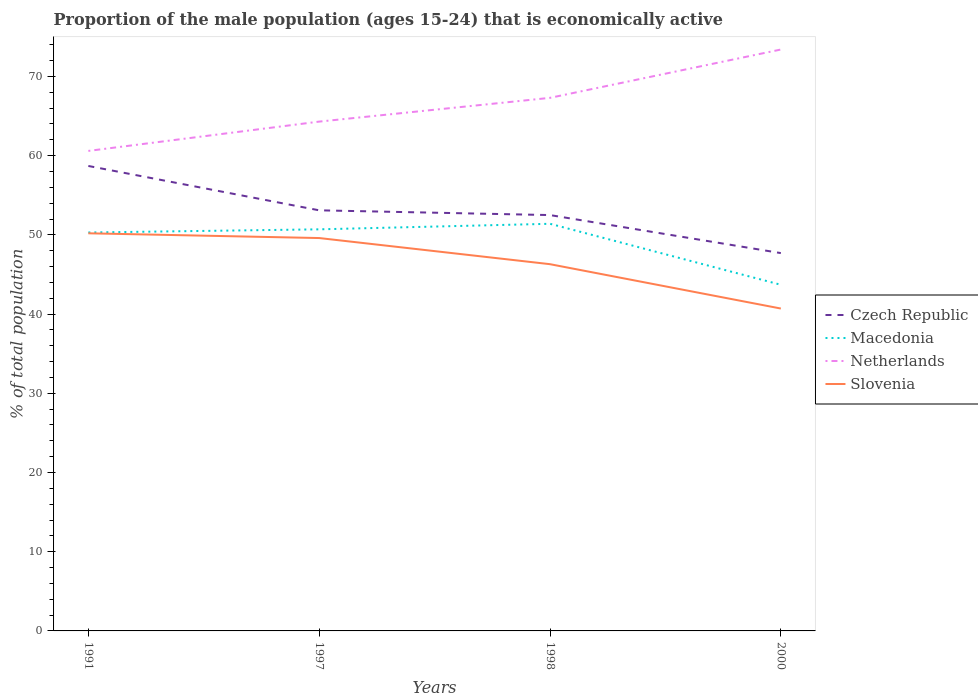How many different coloured lines are there?
Your answer should be very brief. 4. Does the line corresponding to Slovenia intersect with the line corresponding to Czech Republic?
Offer a very short reply. No. Is the number of lines equal to the number of legend labels?
Provide a succinct answer. Yes. Across all years, what is the maximum proportion of the male population that is economically active in Czech Republic?
Provide a succinct answer. 47.7. In which year was the proportion of the male population that is economically active in Macedonia maximum?
Your answer should be very brief. 2000. What is the total proportion of the male population that is economically active in Macedonia in the graph?
Keep it short and to the point. -0.7. Is the proportion of the male population that is economically active in Netherlands strictly greater than the proportion of the male population that is economically active in Macedonia over the years?
Your answer should be very brief. No. How many years are there in the graph?
Provide a succinct answer. 4. What is the difference between two consecutive major ticks on the Y-axis?
Offer a very short reply. 10. Does the graph contain grids?
Your answer should be very brief. No. Where does the legend appear in the graph?
Give a very brief answer. Center right. What is the title of the graph?
Offer a very short reply. Proportion of the male population (ages 15-24) that is economically active. Does "Togo" appear as one of the legend labels in the graph?
Offer a terse response. No. What is the label or title of the Y-axis?
Keep it short and to the point. % of total population. What is the % of total population in Czech Republic in 1991?
Offer a terse response. 58.7. What is the % of total population of Macedonia in 1991?
Offer a terse response. 50.3. What is the % of total population in Netherlands in 1991?
Give a very brief answer. 60.6. What is the % of total population in Slovenia in 1991?
Your response must be concise. 50.2. What is the % of total population in Czech Republic in 1997?
Provide a short and direct response. 53.1. What is the % of total population of Macedonia in 1997?
Offer a terse response. 50.7. What is the % of total population of Netherlands in 1997?
Your response must be concise. 64.3. What is the % of total population of Slovenia in 1997?
Offer a very short reply. 49.6. What is the % of total population of Czech Republic in 1998?
Give a very brief answer. 52.5. What is the % of total population in Macedonia in 1998?
Provide a short and direct response. 51.4. What is the % of total population of Netherlands in 1998?
Your answer should be very brief. 67.3. What is the % of total population in Slovenia in 1998?
Provide a short and direct response. 46.3. What is the % of total population in Czech Republic in 2000?
Give a very brief answer. 47.7. What is the % of total population of Macedonia in 2000?
Ensure brevity in your answer.  43.7. What is the % of total population in Netherlands in 2000?
Offer a very short reply. 73.4. What is the % of total population of Slovenia in 2000?
Offer a terse response. 40.7. Across all years, what is the maximum % of total population in Czech Republic?
Offer a terse response. 58.7. Across all years, what is the maximum % of total population of Macedonia?
Keep it short and to the point. 51.4. Across all years, what is the maximum % of total population of Netherlands?
Ensure brevity in your answer.  73.4. Across all years, what is the maximum % of total population of Slovenia?
Your answer should be very brief. 50.2. Across all years, what is the minimum % of total population in Czech Republic?
Your response must be concise. 47.7. Across all years, what is the minimum % of total population of Macedonia?
Give a very brief answer. 43.7. Across all years, what is the minimum % of total population of Netherlands?
Give a very brief answer. 60.6. Across all years, what is the minimum % of total population of Slovenia?
Your response must be concise. 40.7. What is the total % of total population in Czech Republic in the graph?
Offer a terse response. 212. What is the total % of total population in Macedonia in the graph?
Your answer should be very brief. 196.1. What is the total % of total population of Netherlands in the graph?
Give a very brief answer. 265.6. What is the total % of total population in Slovenia in the graph?
Provide a short and direct response. 186.8. What is the difference between the % of total population in Macedonia in 1991 and that in 1997?
Ensure brevity in your answer.  -0.4. What is the difference between the % of total population in Czech Republic in 1991 and that in 2000?
Offer a very short reply. 11. What is the difference between the % of total population in Macedonia in 1991 and that in 2000?
Give a very brief answer. 6.6. What is the difference between the % of total population of Netherlands in 1991 and that in 2000?
Offer a terse response. -12.8. What is the difference between the % of total population of Slovenia in 1991 and that in 2000?
Offer a terse response. 9.5. What is the difference between the % of total population in Czech Republic in 1997 and that in 1998?
Your response must be concise. 0.6. What is the difference between the % of total population of Czech Republic in 1997 and that in 2000?
Provide a succinct answer. 5.4. What is the difference between the % of total population of Netherlands in 1997 and that in 2000?
Make the answer very short. -9.1. What is the difference between the % of total population in Netherlands in 1998 and that in 2000?
Give a very brief answer. -6.1. What is the difference between the % of total population in Czech Republic in 1991 and the % of total population in Slovenia in 1997?
Provide a short and direct response. 9.1. What is the difference between the % of total population of Macedonia in 1991 and the % of total population of Slovenia in 1997?
Your answer should be compact. 0.7. What is the difference between the % of total population of Netherlands in 1991 and the % of total population of Slovenia in 1997?
Your answer should be compact. 11. What is the difference between the % of total population in Czech Republic in 1991 and the % of total population in Macedonia in 1998?
Give a very brief answer. 7.3. What is the difference between the % of total population in Czech Republic in 1991 and the % of total population in Slovenia in 1998?
Ensure brevity in your answer.  12.4. What is the difference between the % of total population of Czech Republic in 1991 and the % of total population of Macedonia in 2000?
Your answer should be very brief. 15. What is the difference between the % of total population in Czech Republic in 1991 and the % of total population in Netherlands in 2000?
Keep it short and to the point. -14.7. What is the difference between the % of total population in Macedonia in 1991 and the % of total population in Netherlands in 2000?
Offer a terse response. -23.1. What is the difference between the % of total population of Netherlands in 1991 and the % of total population of Slovenia in 2000?
Provide a succinct answer. 19.9. What is the difference between the % of total population of Macedonia in 1997 and the % of total population of Netherlands in 1998?
Make the answer very short. -16.6. What is the difference between the % of total population in Czech Republic in 1997 and the % of total population in Netherlands in 2000?
Provide a succinct answer. -20.3. What is the difference between the % of total population in Czech Republic in 1997 and the % of total population in Slovenia in 2000?
Offer a very short reply. 12.4. What is the difference between the % of total population in Macedonia in 1997 and the % of total population in Netherlands in 2000?
Provide a succinct answer. -22.7. What is the difference between the % of total population of Macedonia in 1997 and the % of total population of Slovenia in 2000?
Provide a short and direct response. 10. What is the difference between the % of total population of Netherlands in 1997 and the % of total population of Slovenia in 2000?
Give a very brief answer. 23.6. What is the difference between the % of total population of Czech Republic in 1998 and the % of total population of Netherlands in 2000?
Your response must be concise. -20.9. What is the difference between the % of total population of Czech Republic in 1998 and the % of total population of Slovenia in 2000?
Provide a short and direct response. 11.8. What is the difference between the % of total population in Netherlands in 1998 and the % of total population in Slovenia in 2000?
Provide a succinct answer. 26.6. What is the average % of total population of Czech Republic per year?
Your response must be concise. 53. What is the average % of total population in Macedonia per year?
Provide a succinct answer. 49.02. What is the average % of total population in Netherlands per year?
Keep it short and to the point. 66.4. What is the average % of total population in Slovenia per year?
Offer a very short reply. 46.7. In the year 1991, what is the difference between the % of total population in Czech Republic and % of total population in Macedonia?
Keep it short and to the point. 8.4. In the year 1991, what is the difference between the % of total population in Czech Republic and % of total population in Netherlands?
Make the answer very short. -1.9. In the year 1991, what is the difference between the % of total population in Czech Republic and % of total population in Slovenia?
Your answer should be very brief. 8.5. In the year 1991, what is the difference between the % of total population of Netherlands and % of total population of Slovenia?
Ensure brevity in your answer.  10.4. In the year 1997, what is the difference between the % of total population in Czech Republic and % of total population in Macedonia?
Make the answer very short. 2.4. In the year 1997, what is the difference between the % of total population in Czech Republic and % of total population in Slovenia?
Provide a succinct answer. 3.5. In the year 1997, what is the difference between the % of total population of Macedonia and % of total population of Netherlands?
Make the answer very short. -13.6. In the year 1997, what is the difference between the % of total population in Netherlands and % of total population in Slovenia?
Offer a very short reply. 14.7. In the year 1998, what is the difference between the % of total population of Czech Republic and % of total population of Netherlands?
Keep it short and to the point. -14.8. In the year 1998, what is the difference between the % of total population in Macedonia and % of total population in Netherlands?
Your answer should be very brief. -15.9. In the year 2000, what is the difference between the % of total population of Czech Republic and % of total population of Macedonia?
Make the answer very short. 4. In the year 2000, what is the difference between the % of total population in Czech Republic and % of total population in Netherlands?
Offer a terse response. -25.7. In the year 2000, what is the difference between the % of total population of Macedonia and % of total population of Netherlands?
Provide a short and direct response. -29.7. In the year 2000, what is the difference between the % of total population of Netherlands and % of total population of Slovenia?
Ensure brevity in your answer.  32.7. What is the ratio of the % of total population in Czech Republic in 1991 to that in 1997?
Ensure brevity in your answer.  1.11. What is the ratio of the % of total population of Macedonia in 1991 to that in 1997?
Ensure brevity in your answer.  0.99. What is the ratio of the % of total population of Netherlands in 1991 to that in 1997?
Your answer should be compact. 0.94. What is the ratio of the % of total population in Slovenia in 1991 to that in 1997?
Make the answer very short. 1.01. What is the ratio of the % of total population in Czech Republic in 1991 to that in 1998?
Keep it short and to the point. 1.12. What is the ratio of the % of total population in Macedonia in 1991 to that in 1998?
Give a very brief answer. 0.98. What is the ratio of the % of total population of Netherlands in 1991 to that in 1998?
Your answer should be very brief. 0.9. What is the ratio of the % of total population of Slovenia in 1991 to that in 1998?
Offer a very short reply. 1.08. What is the ratio of the % of total population in Czech Republic in 1991 to that in 2000?
Provide a short and direct response. 1.23. What is the ratio of the % of total population of Macedonia in 1991 to that in 2000?
Offer a terse response. 1.15. What is the ratio of the % of total population in Netherlands in 1991 to that in 2000?
Keep it short and to the point. 0.83. What is the ratio of the % of total population in Slovenia in 1991 to that in 2000?
Ensure brevity in your answer.  1.23. What is the ratio of the % of total population of Czech Republic in 1997 to that in 1998?
Your answer should be compact. 1.01. What is the ratio of the % of total population of Macedonia in 1997 to that in 1998?
Provide a short and direct response. 0.99. What is the ratio of the % of total population of Netherlands in 1997 to that in 1998?
Give a very brief answer. 0.96. What is the ratio of the % of total population in Slovenia in 1997 to that in 1998?
Ensure brevity in your answer.  1.07. What is the ratio of the % of total population in Czech Republic in 1997 to that in 2000?
Give a very brief answer. 1.11. What is the ratio of the % of total population in Macedonia in 1997 to that in 2000?
Make the answer very short. 1.16. What is the ratio of the % of total population of Netherlands in 1997 to that in 2000?
Keep it short and to the point. 0.88. What is the ratio of the % of total population in Slovenia in 1997 to that in 2000?
Give a very brief answer. 1.22. What is the ratio of the % of total population of Czech Republic in 1998 to that in 2000?
Your answer should be very brief. 1.1. What is the ratio of the % of total population of Macedonia in 1998 to that in 2000?
Offer a terse response. 1.18. What is the ratio of the % of total population in Netherlands in 1998 to that in 2000?
Provide a succinct answer. 0.92. What is the ratio of the % of total population in Slovenia in 1998 to that in 2000?
Make the answer very short. 1.14. What is the difference between the highest and the second highest % of total population in Slovenia?
Offer a terse response. 0.6. What is the difference between the highest and the lowest % of total population in Slovenia?
Your answer should be very brief. 9.5. 